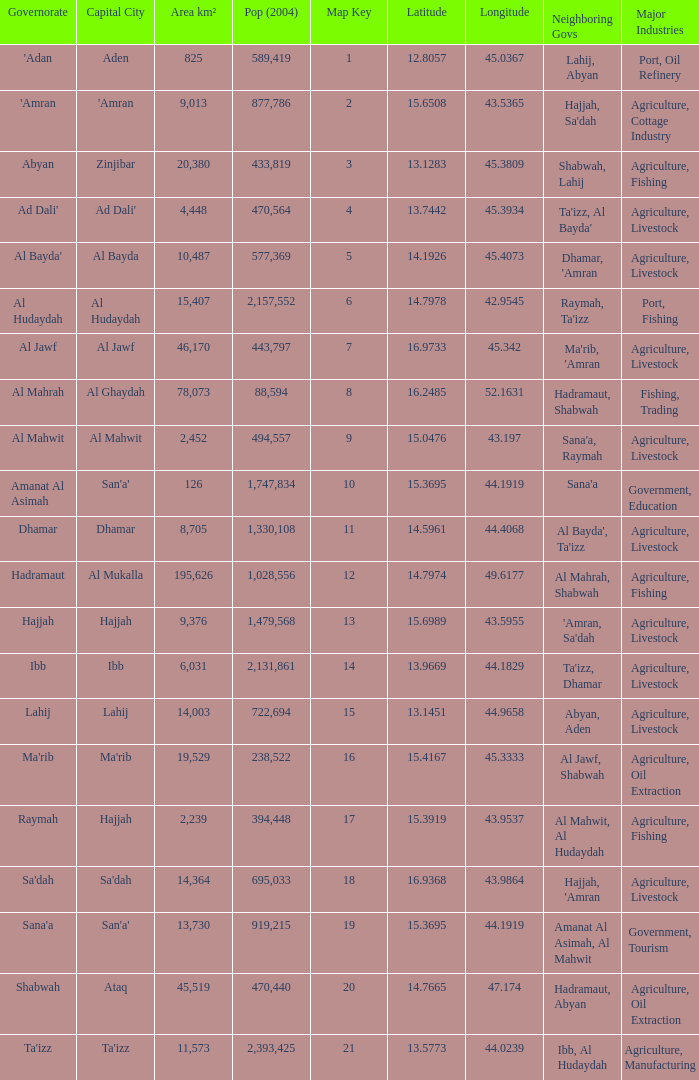How many Map Key has an Area km² larger than 14,003 and a Capital City of al mukalla, and a Pop (2004) larger than 1,028,556? None. 